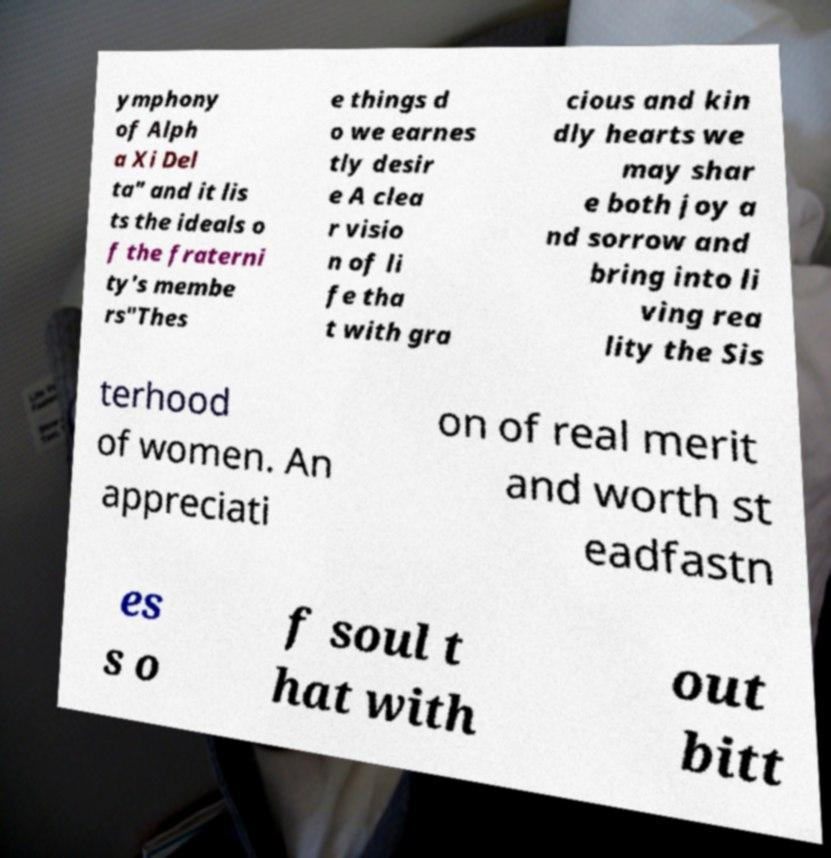I need the written content from this picture converted into text. Can you do that? ymphony of Alph a Xi Del ta" and it lis ts the ideals o f the fraterni ty's membe rs"Thes e things d o we earnes tly desir e A clea r visio n of li fe tha t with gra cious and kin dly hearts we may shar e both joy a nd sorrow and bring into li ving rea lity the Sis terhood of women. An appreciati on of real merit and worth st eadfastn es s o f soul t hat with out bitt 